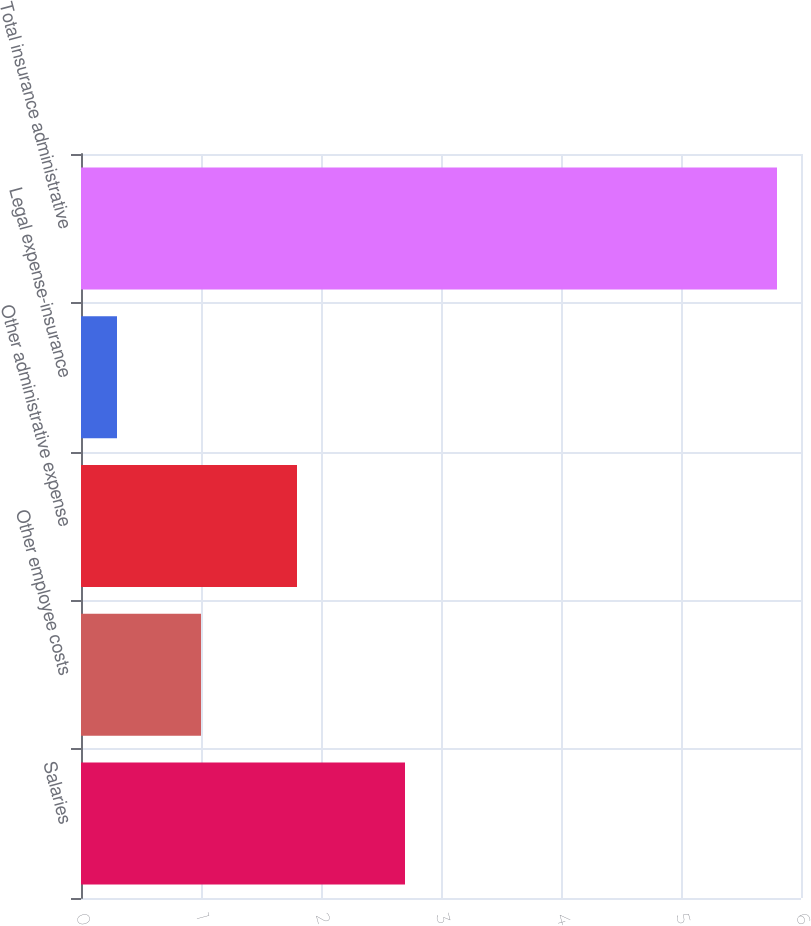Convert chart to OTSL. <chart><loc_0><loc_0><loc_500><loc_500><bar_chart><fcel>Salaries<fcel>Other employee costs<fcel>Other administrative expense<fcel>Legal expense-insurance<fcel>Total insurance administrative<nl><fcel>2.7<fcel>1<fcel>1.8<fcel>0.3<fcel>5.8<nl></chart> 